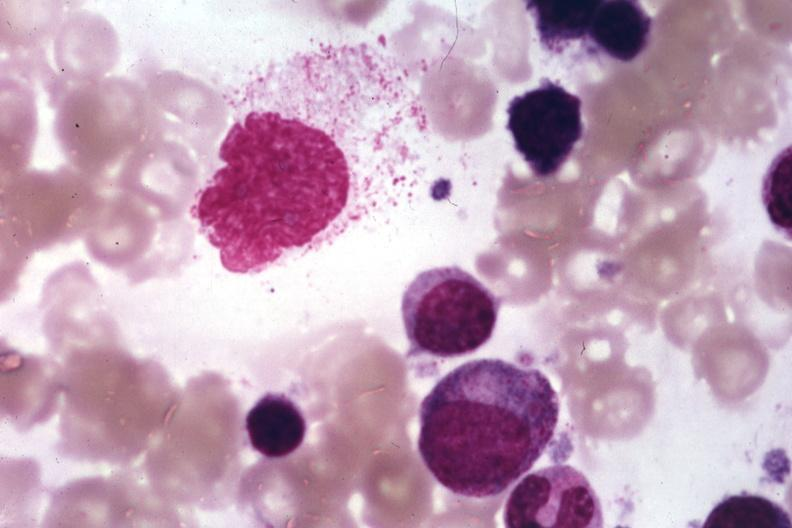s large cell lymphoma present?
Answer the question using a single word or phrase. No 